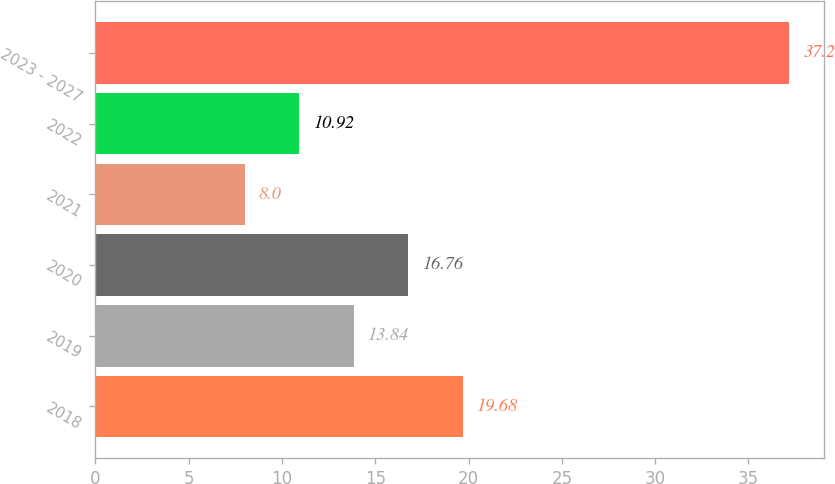<chart> <loc_0><loc_0><loc_500><loc_500><bar_chart><fcel>2018<fcel>2019<fcel>2020<fcel>2021<fcel>2022<fcel>2023 - 2027<nl><fcel>19.68<fcel>13.84<fcel>16.76<fcel>8<fcel>10.92<fcel>37.2<nl></chart> 